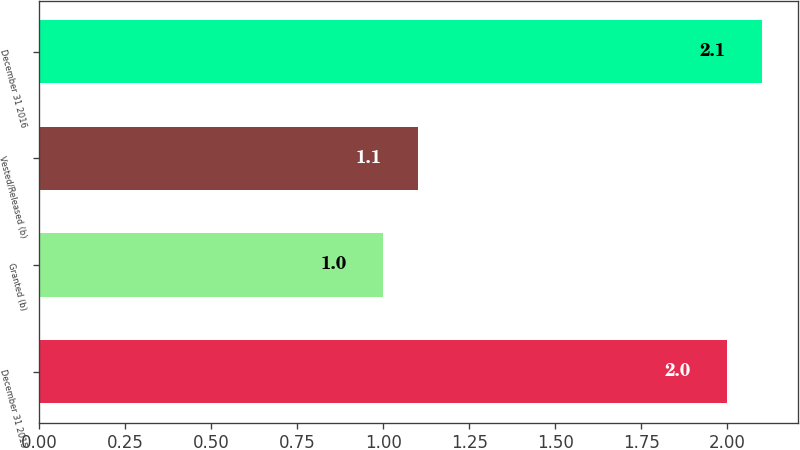Convert chart. <chart><loc_0><loc_0><loc_500><loc_500><bar_chart><fcel>December 31 2015<fcel>Granted (b)<fcel>Vested/Released (b)<fcel>December 31 2016<nl><fcel>2<fcel>1<fcel>1.1<fcel>2.1<nl></chart> 